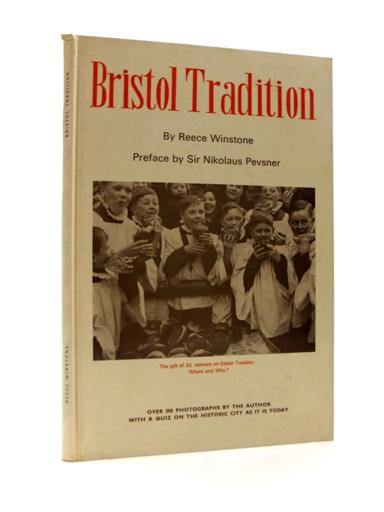Can you describe the expressions and attire of the children in the photograph? In the photograph, the children are seen wearing traditional choir robes, which indicate their likely role as choristers in a church setting. Their expressions are joyful and lively, suggesting a moment of celebration or a significant event in their communal religious life. 